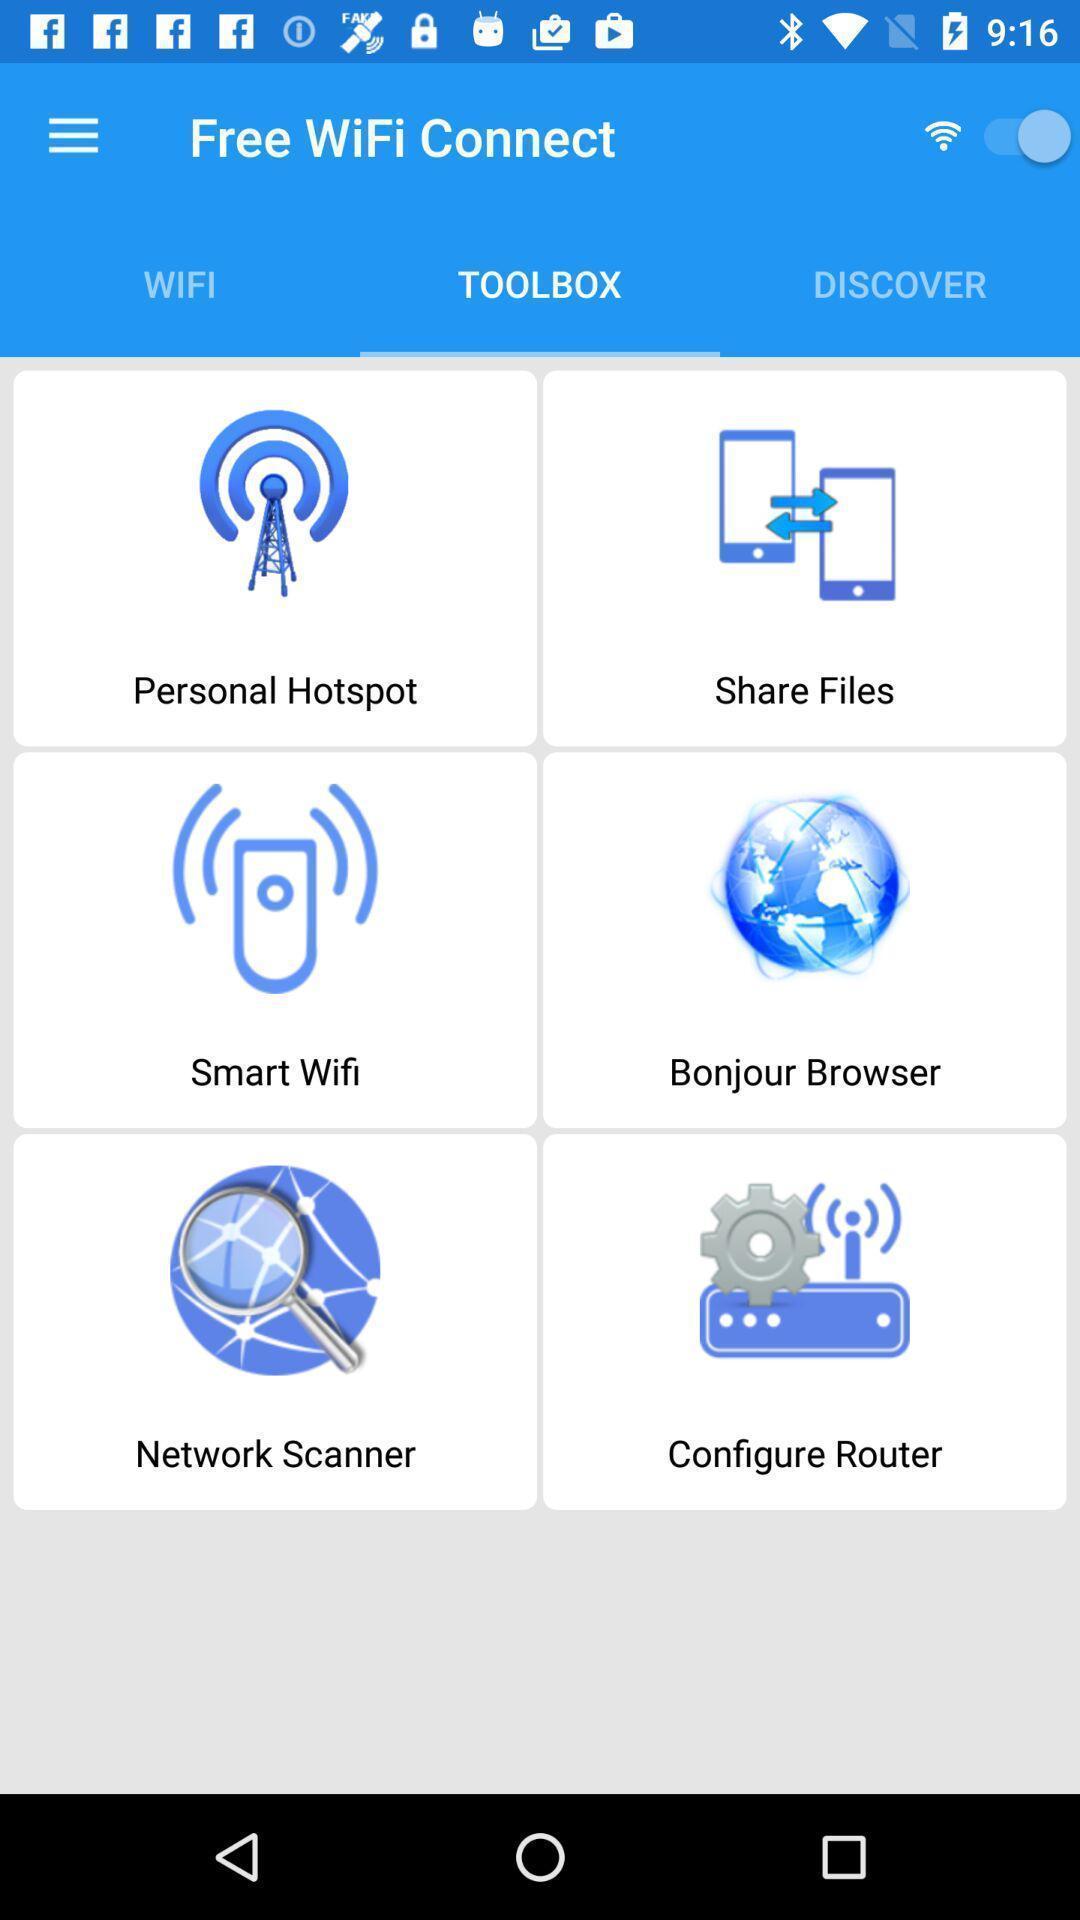Explain what's happening in this screen capture. Screen showing tool box. 